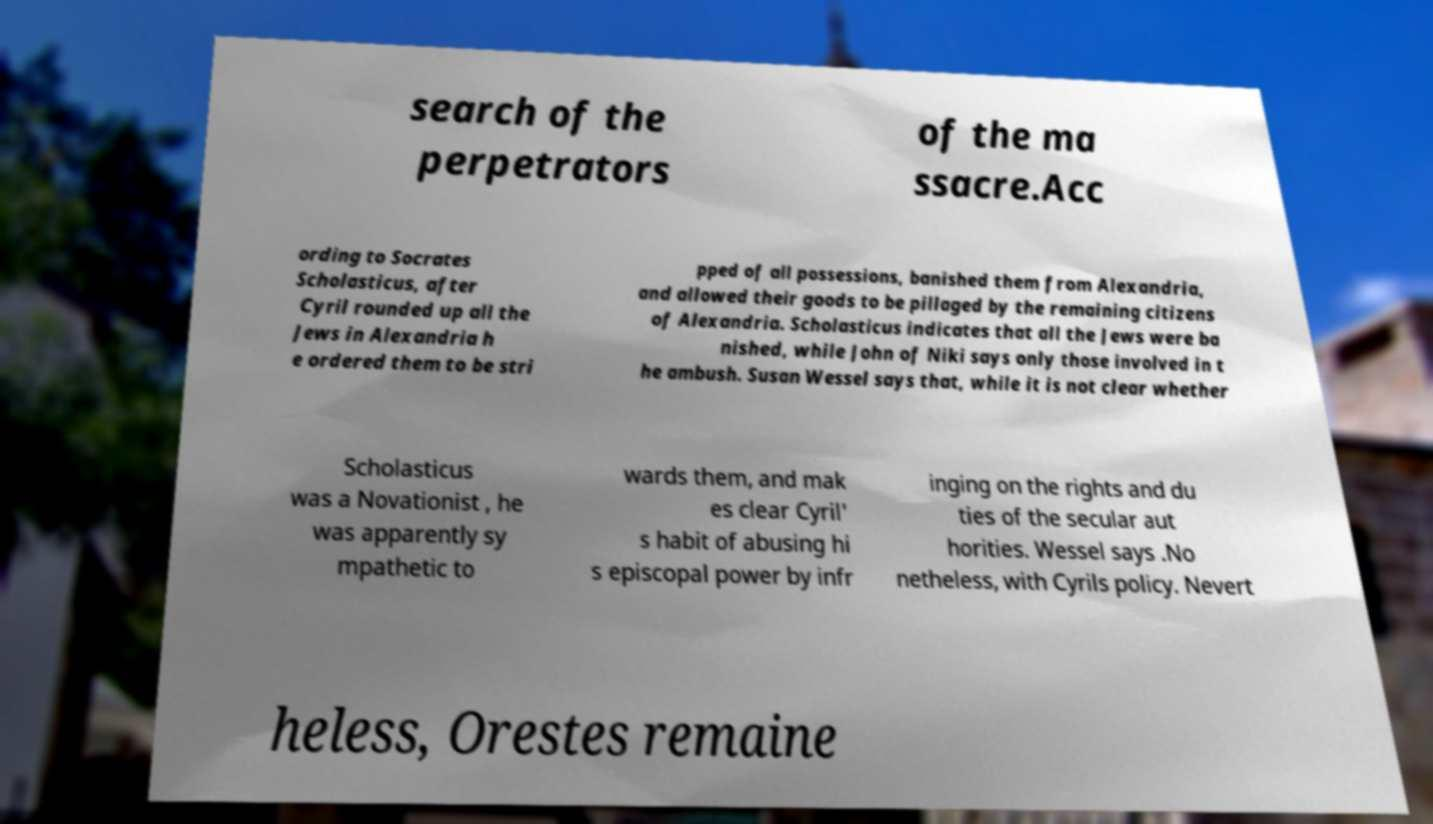Please identify and transcribe the text found in this image. search of the perpetrators of the ma ssacre.Acc ording to Socrates Scholasticus, after Cyril rounded up all the Jews in Alexandria h e ordered them to be stri pped of all possessions, banished them from Alexandria, and allowed their goods to be pillaged by the remaining citizens of Alexandria. Scholasticus indicates that all the Jews were ba nished, while John of Niki says only those involved in t he ambush. Susan Wessel says that, while it is not clear whether Scholasticus was a Novationist , he was apparently sy mpathetic to wards them, and mak es clear Cyril' s habit of abusing hi s episcopal power by infr inging on the rights and du ties of the secular aut horities. Wessel says .No netheless, with Cyrils policy. Nevert heless, Orestes remaine 